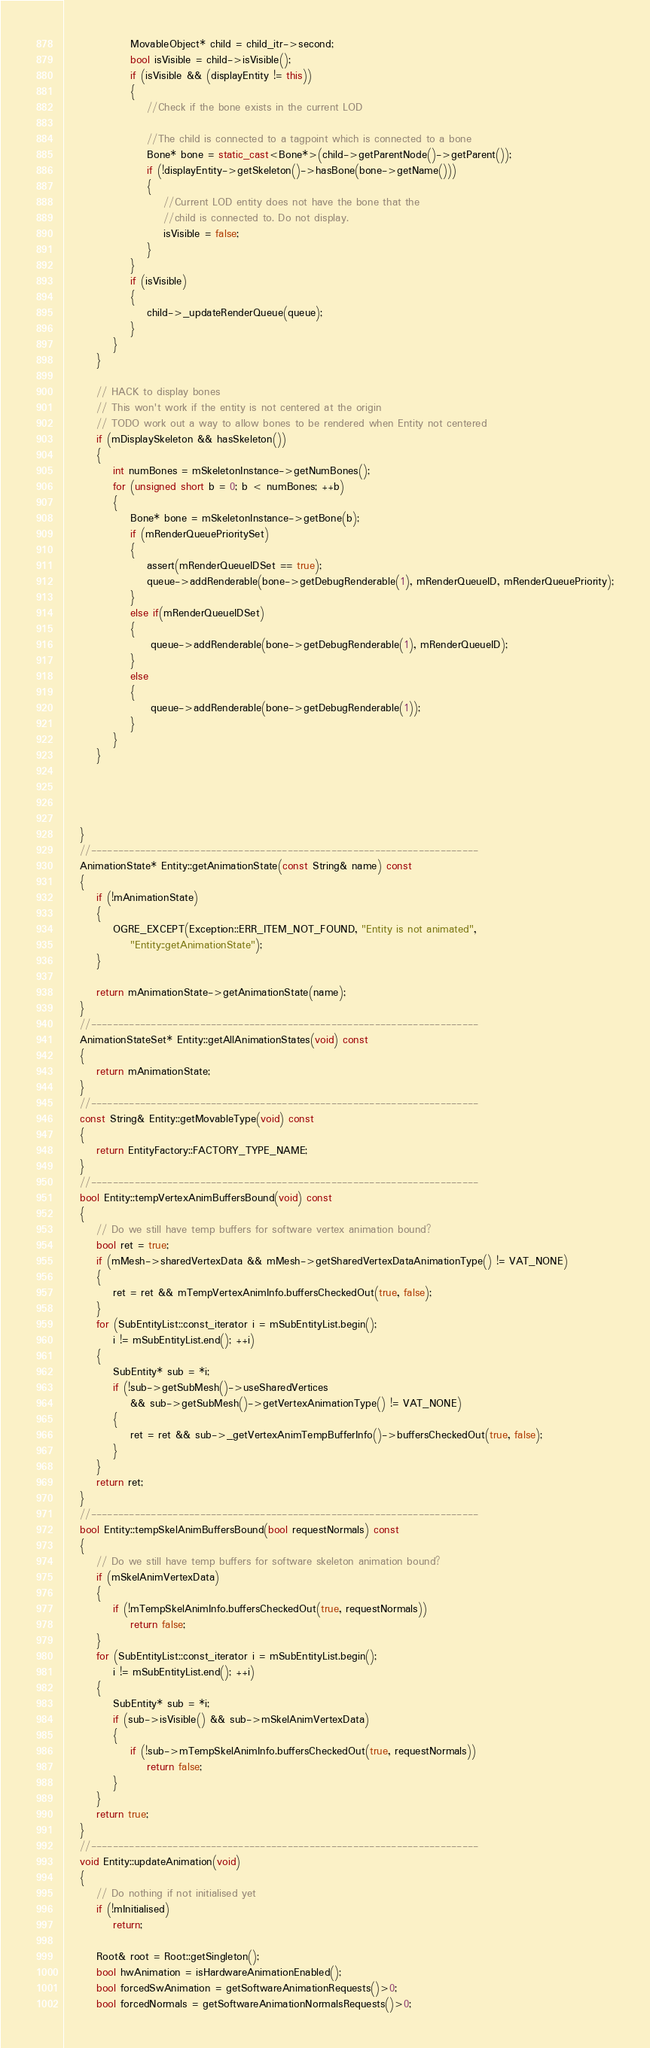Convert code to text. <code><loc_0><loc_0><loc_500><loc_500><_C++_>                MovableObject* child = child_itr->second;
                bool isVisible = child->isVisible();
                if (isVisible && (displayEntity != this))
                {
                    //Check if the bone exists in the current LOD

                    //The child is connected to a tagpoint which is connected to a bone
                    Bone* bone = static_cast<Bone*>(child->getParentNode()->getParent());
                    if (!displayEntity->getSkeleton()->hasBone(bone->getName()))
                    {
                        //Current LOD entity does not have the bone that the
                        //child is connected to. Do not display.
                        isVisible = false;
                    }
                }
                if (isVisible)
                {
                    child->_updateRenderQueue(queue);
                }   
            }
        }

        // HACK to display bones
        // This won't work if the entity is not centered at the origin
        // TODO work out a way to allow bones to be rendered when Entity not centered
        if (mDisplaySkeleton && hasSkeleton())
        {
            int numBones = mSkeletonInstance->getNumBones();
            for (unsigned short b = 0; b < numBones; ++b)
            {
                Bone* bone = mSkeletonInstance->getBone(b);
				if (mRenderQueuePrioritySet)
				{
					assert(mRenderQueueIDSet == true);
					queue->addRenderable(bone->getDebugRenderable(1), mRenderQueueID, mRenderQueuePriority);
				}
				else if(mRenderQueueIDSet)
                {
                     queue->addRenderable(bone->getDebugRenderable(1), mRenderQueueID);
                } 
				else 
				{
                     queue->addRenderable(bone->getDebugRenderable(1));
                }
            }
        }




    }
    //-----------------------------------------------------------------------
    AnimationState* Entity::getAnimationState(const String& name) const
    {
        if (!mAnimationState)
        {
            OGRE_EXCEPT(Exception::ERR_ITEM_NOT_FOUND, "Entity is not animated",
                "Entity::getAnimationState");
        }

		return mAnimationState->getAnimationState(name);
    }
    //-----------------------------------------------------------------------
    AnimationStateSet* Entity::getAllAnimationStates(void) const
    {
        return mAnimationState;
    }
    //-----------------------------------------------------------------------
    const String& Entity::getMovableType(void) const
    {
		return EntityFactory::FACTORY_TYPE_NAME;
    }
	//-----------------------------------------------------------------------
	bool Entity::tempVertexAnimBuffersBound(void) const
	{
		// Do we still have temp buffers for software vertex animation bound?
		bool ret = true;
		if (mMesh->sharedVertexData && mMesh->getSharedVertexDataAnimationType() != VAT_NONE)
		{
			ret = ret && mTempVertexAnimInfo.buffersCheckedOut(true, false);
		}
		for (SubEntityList::const_iterator i = mSubEntityList.begin();
			i != mSubEntityList.end(); ++i)
		{
			SubEntity* sub = *i;
			if (!sub->getSubMesh()->useSharedVertices
				&& sub->getSubMesh()->getVertexAnimationType() != VAT_NONE)
			{
				ret = ret && sub->_getVertexAnimTempBufferInfo()->buffersCheckedOut(true, false);
			}
		}
		return ret;
	}
    //-----------------------------------------------------------------------
    bool Entity::tempSkelAnimBuffersBound(bool requestNormals) const
    {
        // Do we still have temp buffers for software skeleton animation bound?
        if (mSkelAnimVertexData)
        {
            if (!mTempSkelAnimInfo.buffersCheckedOut(true, requestNormals))
                return false;
        }
        for (SubEntityList::const_iterator i = mSubEntityList.begin();
            i != mSubEntityList.end(); ++i)
        {
            SubEntity* sub = *i;
            if (sub->isVisible() && sub->mSkelAnimVertexData)
            {
                if (!sub->mTempSkelAnimInfo.buffersCheckedOut(true, requestNormals))
                    return false;
            }
        }
        return true;
    }
    //-----------------------------------------------------------------------
    void Entity::updateAnimation(void)
    {
		// Do nothing if not initialised yet
		if (!mInitialised)
			return;

		Root& root = Root::getSingleton();
		bool hwAnimation = isHardwareAnimationEnabled();
		bool forcedSwAnimation = getSoftwareAnimationRequests()>0;
		bool forcedNormals = getSoftwareAnimationNormalsRequests()>0;</code> 